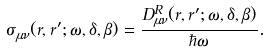Convert formula to latex. <formula><loc_0><loc_0><loc_500><loc_500>\sigma ^ { \ } _ { \mu \nu } ( r , r ^ { \prime } ; \omega , \delta , \beta ) = \frac { D ^ { R } _ { \mu \nu } ( r , r ^ { \prime } ; \omega , \delta , \beta ) } { \hbar { \omega } } .</formula> 